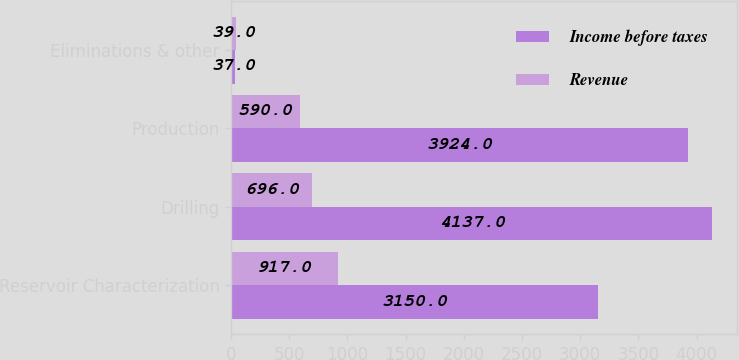<chart> <loc_0><loc_0><loc_500><loc_500><stacked_bar_chart><ecel><fcel>Reservoir Characterization<fcel>Drilling<fcel>Production<fcel>Eliminations & other<nl><fcel>Income before taxes<fcel>3150<fcel>4137<fcel>3924<fcel>37<nl><fcel>Revenue<fcel>917<fcel>696<fcel>590<fcel>39<nl></chart> 